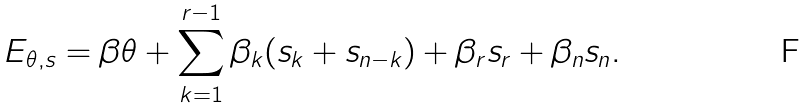<formula> <loc_0><loc_0><loc_500><loc_500>E _ { \theta , s } = \beta \theta + \sum _ { k = 1 } ^ { r - 1 } \beta _ { k } ( s _ { k } + s _ { n - k } ) + \beta _ { r } s _ { r } + \beta _ { n } s _ { n } .</formula> 